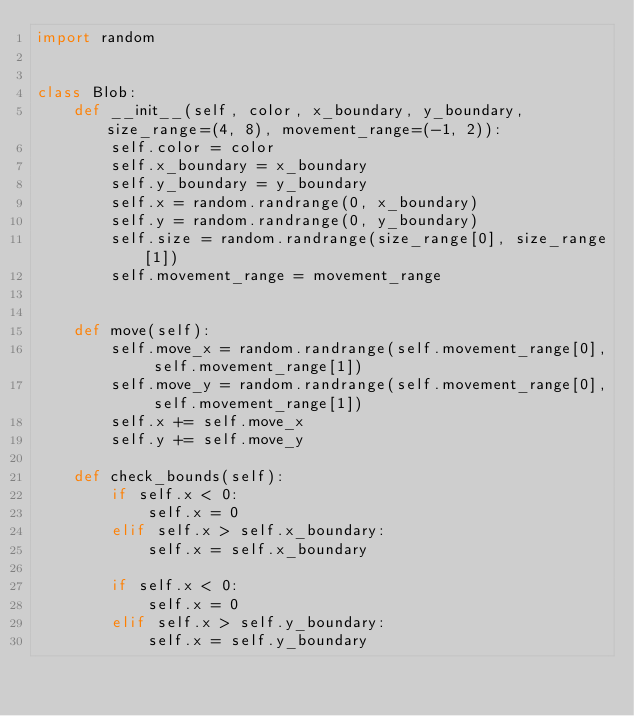Convert code to text. <code><loc_0><loc_0><loc_500><loc_500><_Python_>import random


class Blob:
    def __init__(self, color, x_boundary, y_boundary, size_range=(4, 8), movement_range=(-1, 2)):
        self.color = color
        self.x_boundary = x_boundary
        self.y_boundary = y_boundary
        self.x = random.randrange(0, x_boundary)
        self.y = random.randrange(0, y_boundary)
        self.size = random.randrange(size_range[0], size_range[1])
        self.movement_range = movement_range


    def move(self):
        self.move_x = random.randrange(self.movement_range[0], self.movement_range[1])
        self.move_y = random.randrange(self.movement_range[0], self.movement_range[1])
        self.x += self.move_x
        self.y += self.move_y

    def check_bounds(self):
        if self.x < 0:
            self.x = 0
        elif self.x > self.x_boundary:
            self.x = self.x_boundary

        if self.x < 0:
            self.x = 0
        elif self.x > self.y_boundary:
            self.x = self.y_boundary</code> 